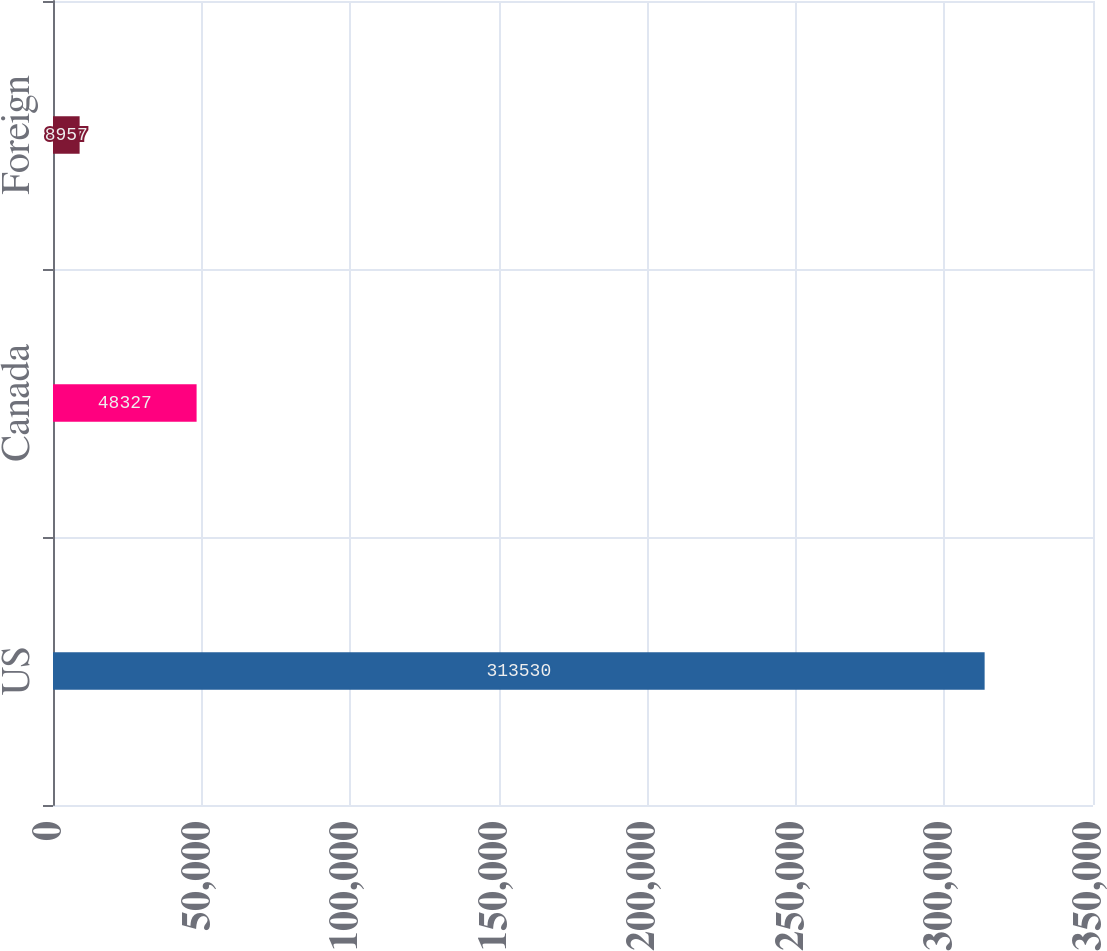Convert chart. <chart><loc_0><loc_0><loc_500><loc_500><bar_chart><fcel>US<fcel>Canada<fcel>Foreign<nl><fcel>313530<fcel>48327<fcel>8957<nl></chart> 